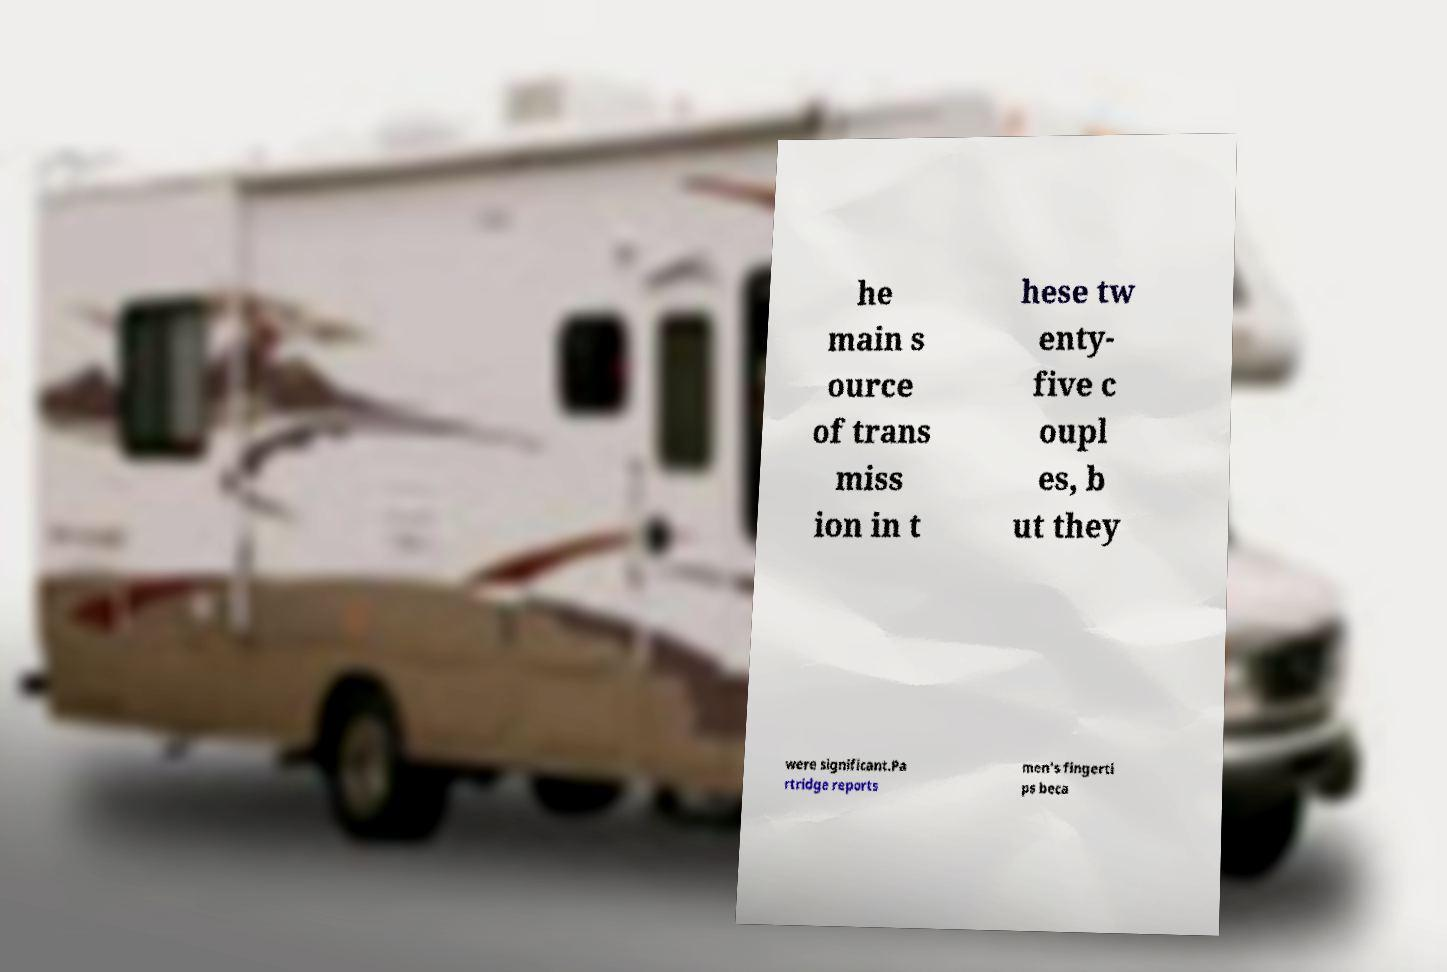There's text embedded in this image that I need extracted. Can you transcribe it verbatim? he main s ource of trans miss ion in t hese tw enty- five c oupl es, b ut they were significant.Pa rtridge reports men's fingerti ps beca 